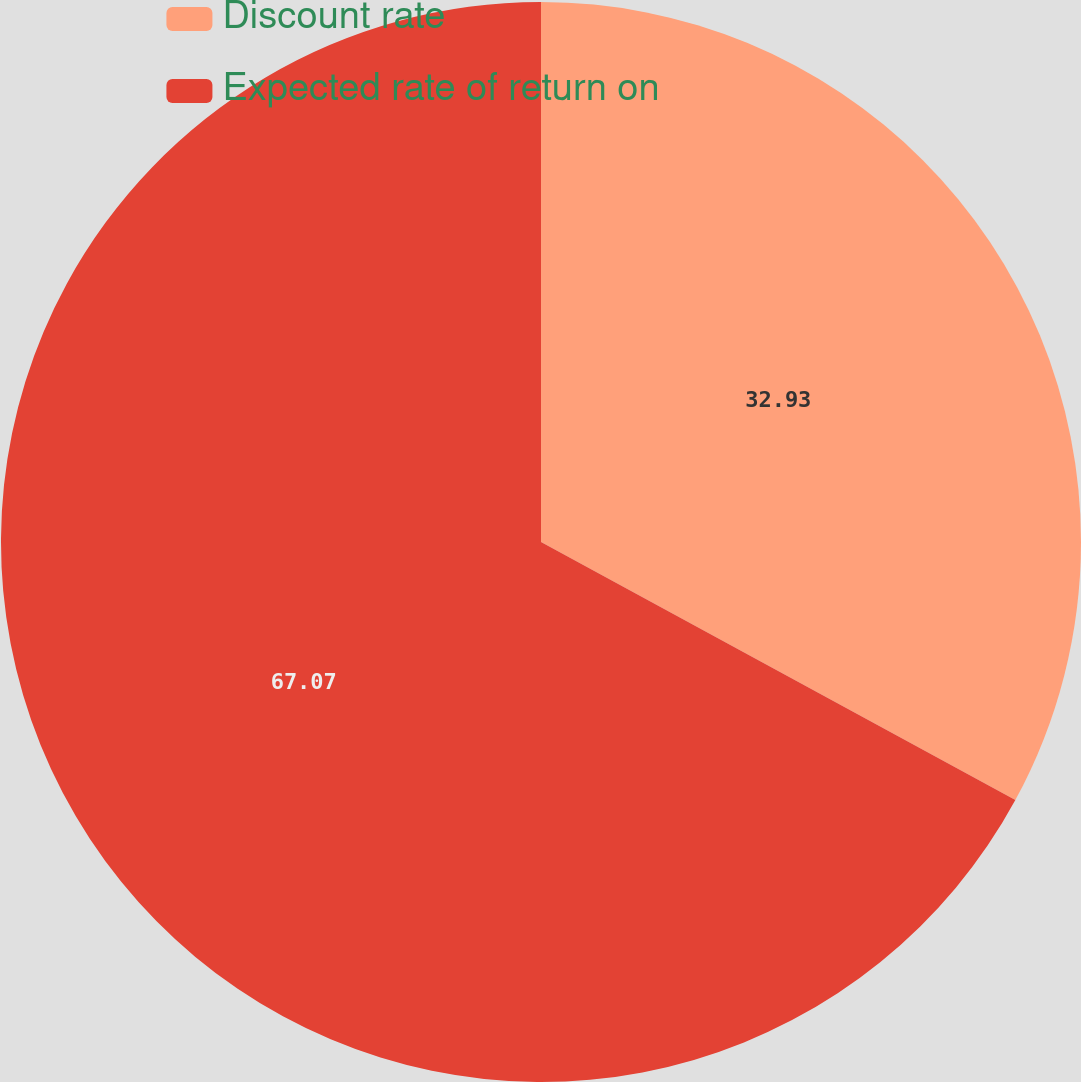Convert chart to OTSL. <chart><loc_0><loc_0><loc_500><loc_500><pie_chart><fcel>Discount rate<fcel>Expected rate of return on<nl><fcel>32.93%<fcel>67.07%<nl></chart> 